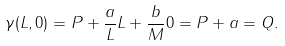Convert formula to latex. <formula><loc_0><loc_0><loc_500><loc_500>\gamma ( L , 0 ) = P + \frac { a } { L } L + \frac { b } { M } 0 = P + a = Q .</formula> 